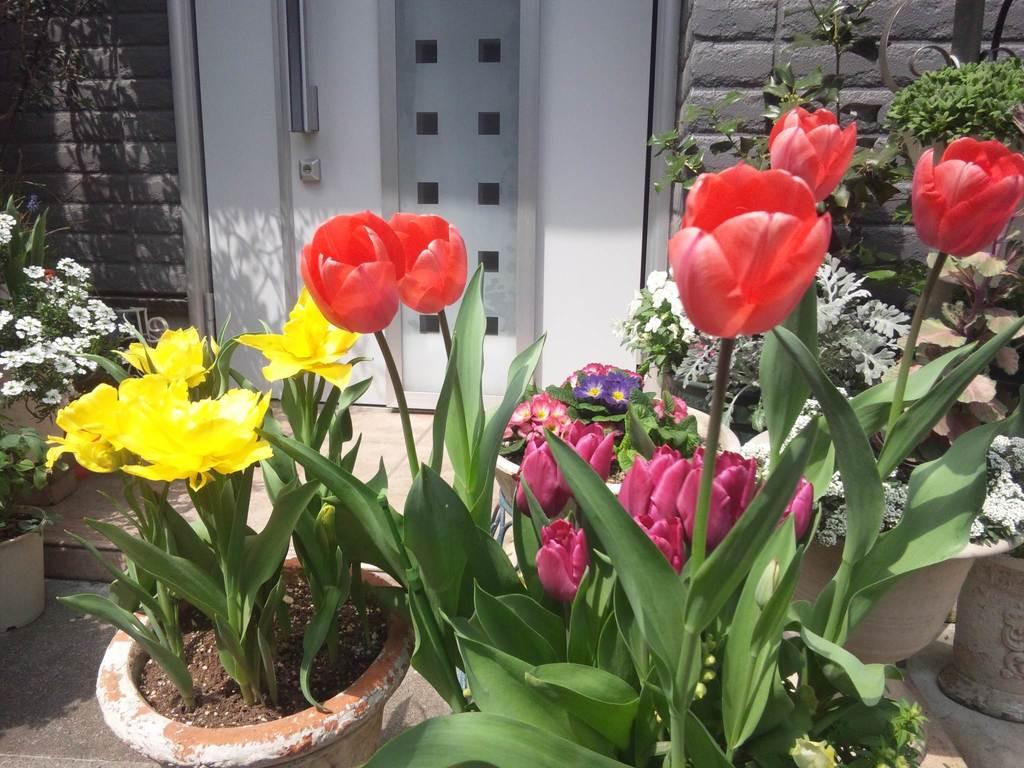What can be seen on both sides of the image? There are flower pots on both the right and left sides of the image. What is visible in the background of the image? There is a door and walls in the background of the image. How many mouths can be seen on the flower pots in the image? There are no mouths present on the flower pots in the image, as flower pots are inanimate objects and do not have mouths. 